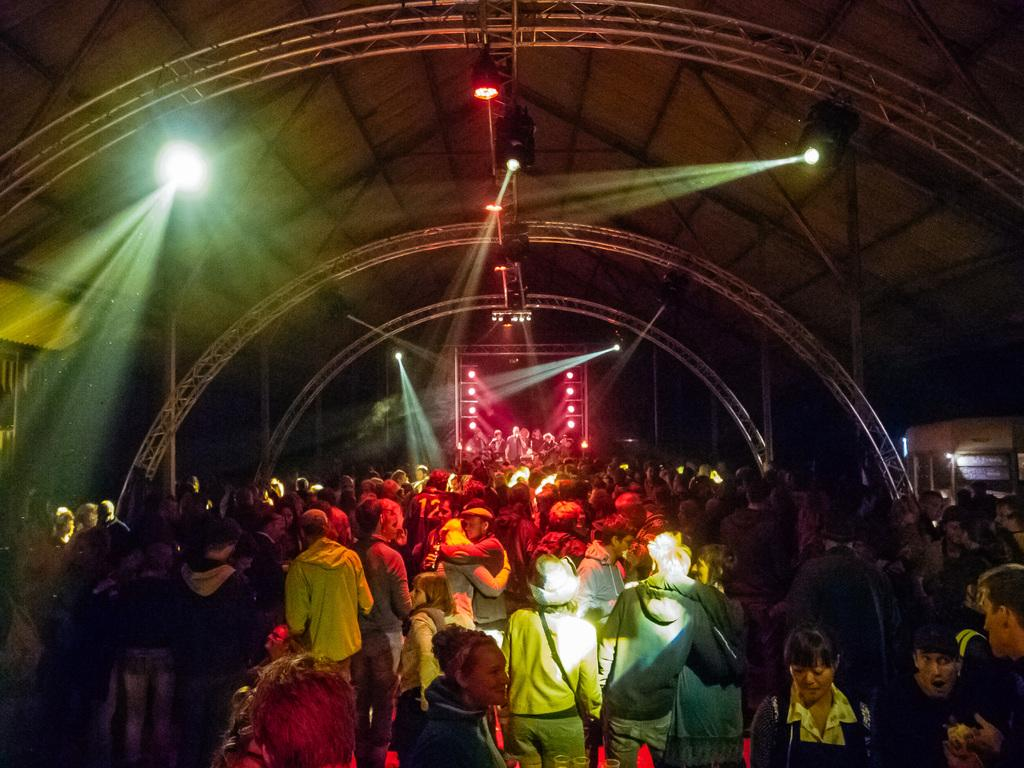What are the people in the image doing? The people in the image are dancing. What architectural features can be seen in the image? There are arches and frames in the image. What type of illumination is present in the image? There are lights in the image. What part of a building is visible in the image? The rooftop is visible in the image. How many balls are being juggled by the father in the image? There is no father or balls present in the image. 